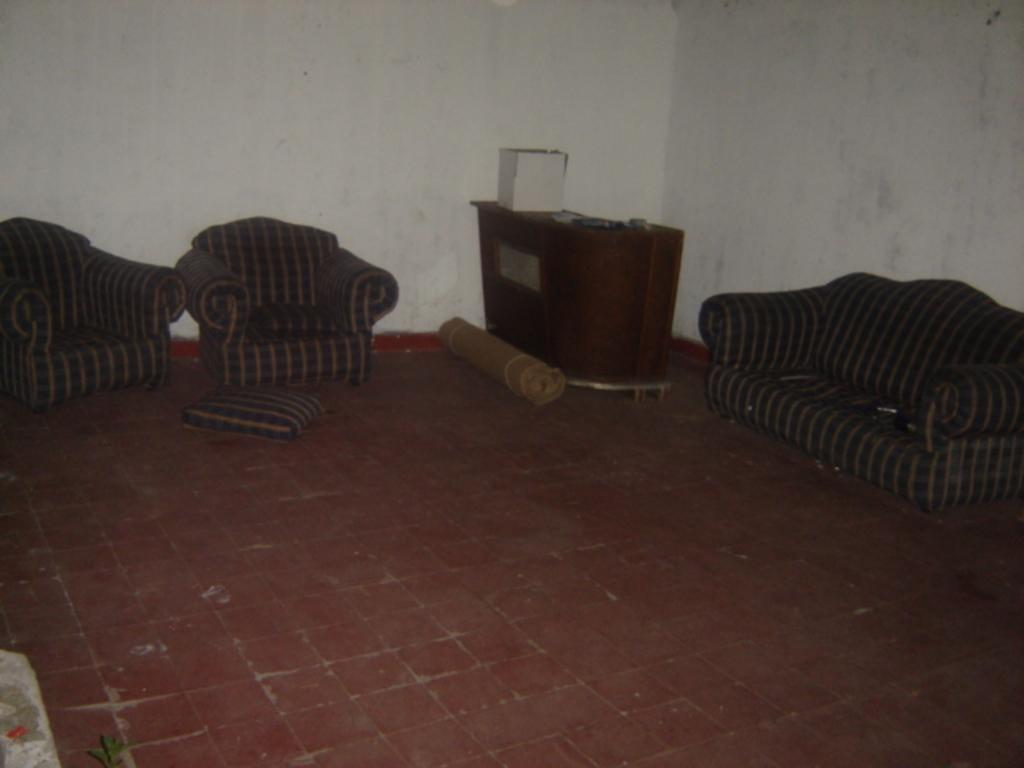What is the color of the wall in the image? The wall in the image is white. What type of furniture is present in the image? There are sofas in the image. What can be seen on the floor in the image? There is a mat in the image. What might be used for comfort or support while sitting? There is a pillow in the image. What page of the book is the person reading in the image? There is no book or person reading in the image; it only features a white wall, sofas, a mat, and a pillow. 